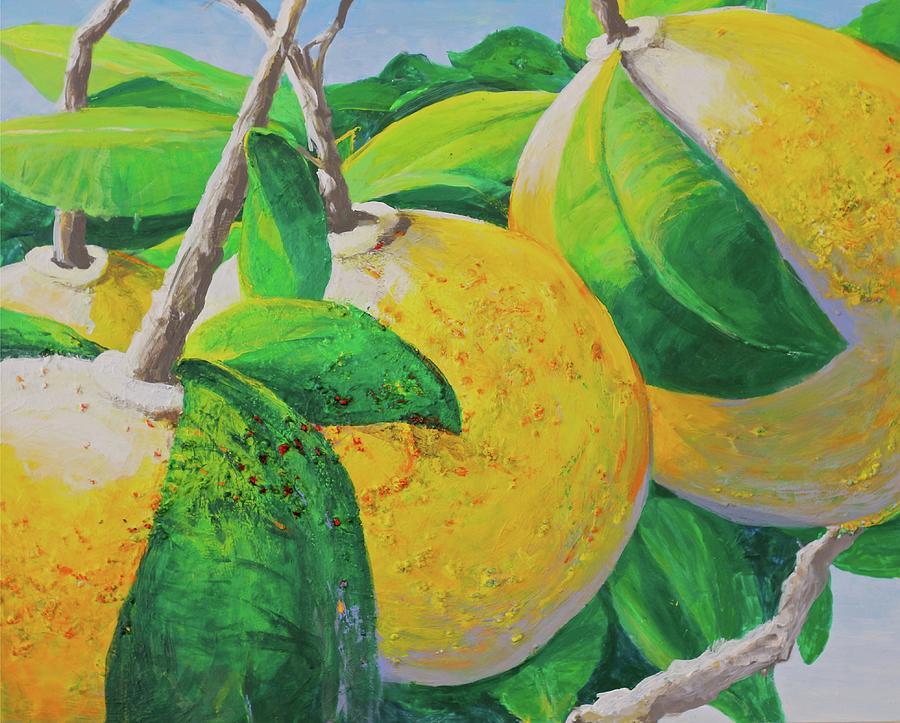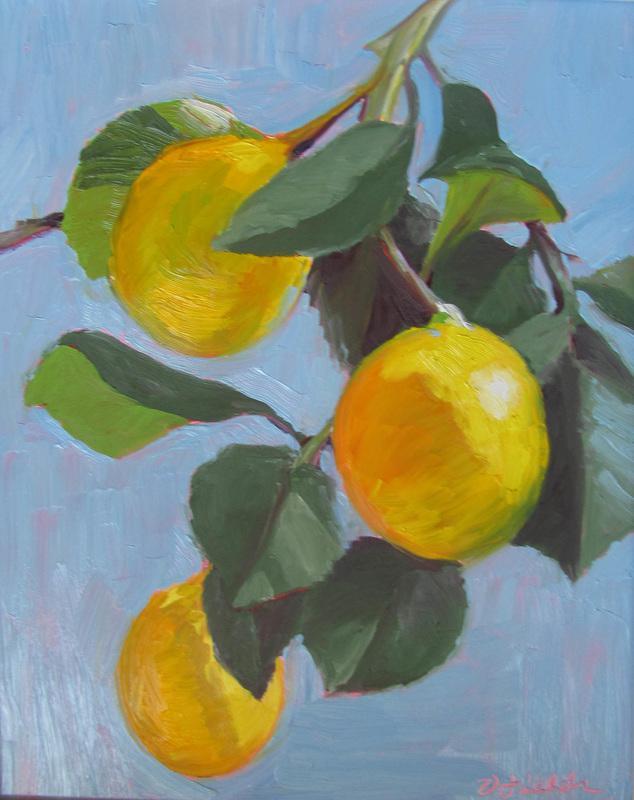The first image is the image on the left, the second image is the image on the right. For the images displayed, is the sentence "There are 6 lemons" factually correct? Answer yes or no. Yes. 